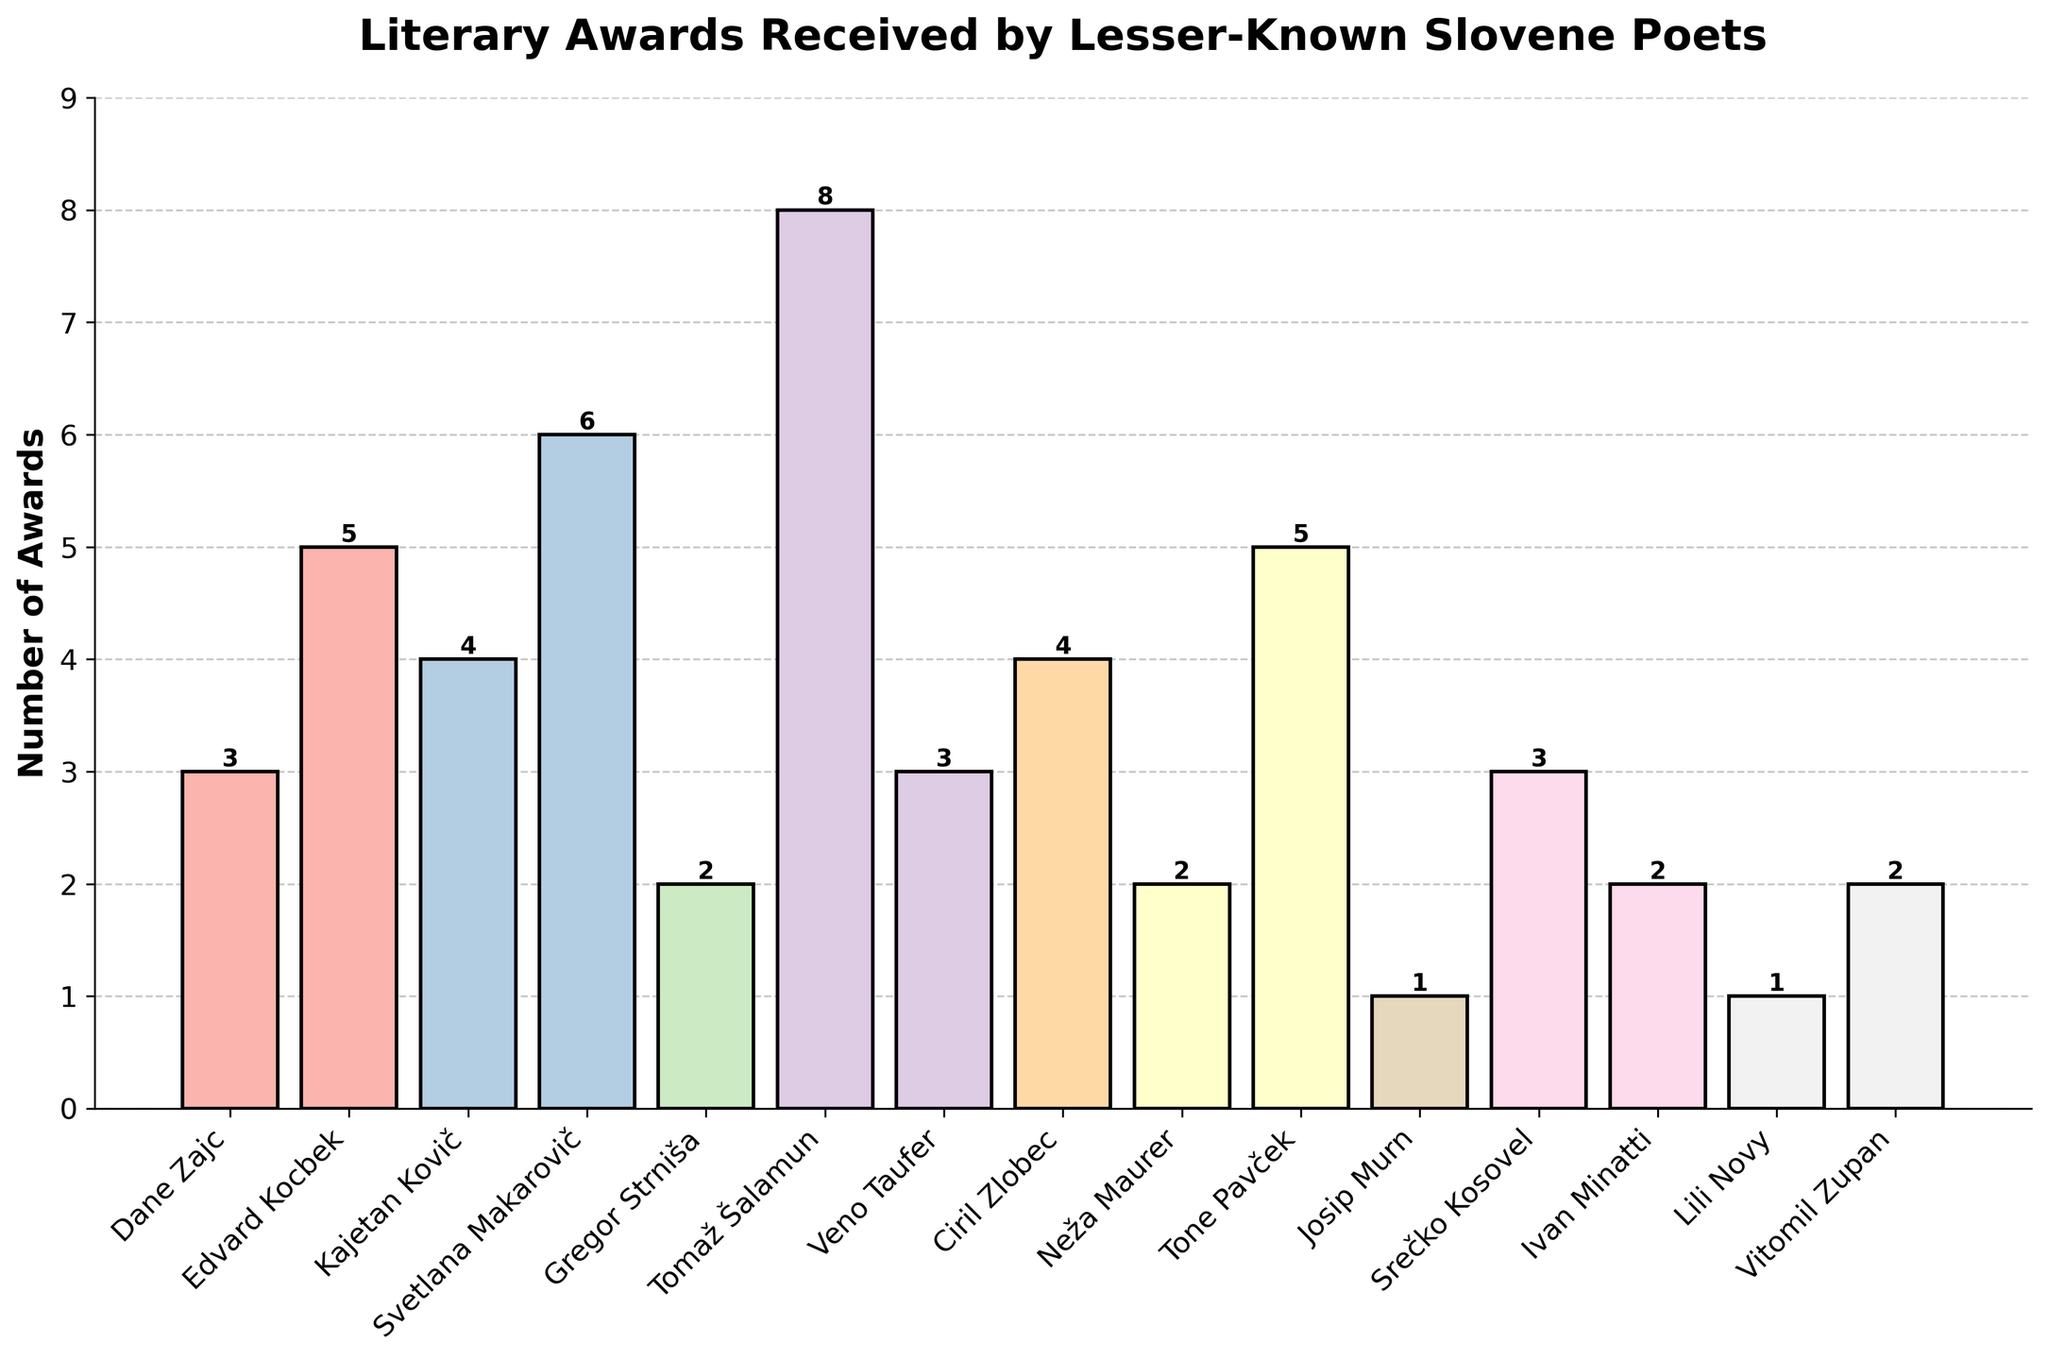What are the poets with the highest and lowest number of awards, and how many did they receive? Svetlana Makarovič received the highest number of awards (6) while Josip Murn and Lili Novy both received the lowest number (1).
Answer: Svetlana Makarovič (6), Josip Murn & Lili Novy (1) How many poets received exactly 3 awards? By counting the poets who received exactly 3 awards: Dane Zajc, Veno Taufer, and Srečko Kosovel, we find the total is 3.
Answer: 3 What's the difference in the number of awards between Tomaž Šalamun and Gregor Strniša? Tomaž Šalamun received 8 awards and Gregor Strniša received 2 awards. The difference is 8 - 2 = 6.
Answer: 6 How many poets received more than 4 awards? Svetlana Makarovič, Tomaž Šalamun, Edvard Kocbek, and Tone Pavček received more than 4 awards. By counting them, we get 4 poets.
Answer: 4 What's the average number of awards received by the poets? Summing the awards (3 + 5 + 4 + 6 + 2 + 8 + 3 + 4 + 2 + 5 + 1 + 3 + 2 + 1 + 2 = 51) and dividing by the number of poets (15), the average is 51/15 = 3.4.
Answer: 3.4 Which poet's bar is colored closest to the middle of the spectrum? By visual inspection of the pastel color gradient, Edvard Kocbek's bar appears to be closest to the middle of the color spectrum.
Answer: Edvard Kocbek Which three poets received the same number of awards? Dane Zajc, Veno Taufer, and Srečko Kosovel each received 3 awards.
Answer: Dane Zajc, Veno Taufer, Srečko Kosovel If you sum the number of awards received by the poets with the 2nd most and 2nd least number of awards, what is the total? The poets with the 2nd most awards are Tomaž Šalamun (8) and those with the 2nd least are Gregor Strniša, Neža Maurer, Ivan Minatti, and Vitomil Zupan (2 each). Summing these: 8 + 2 + 2 + 2 + 2 = 16.
Answer: 16 